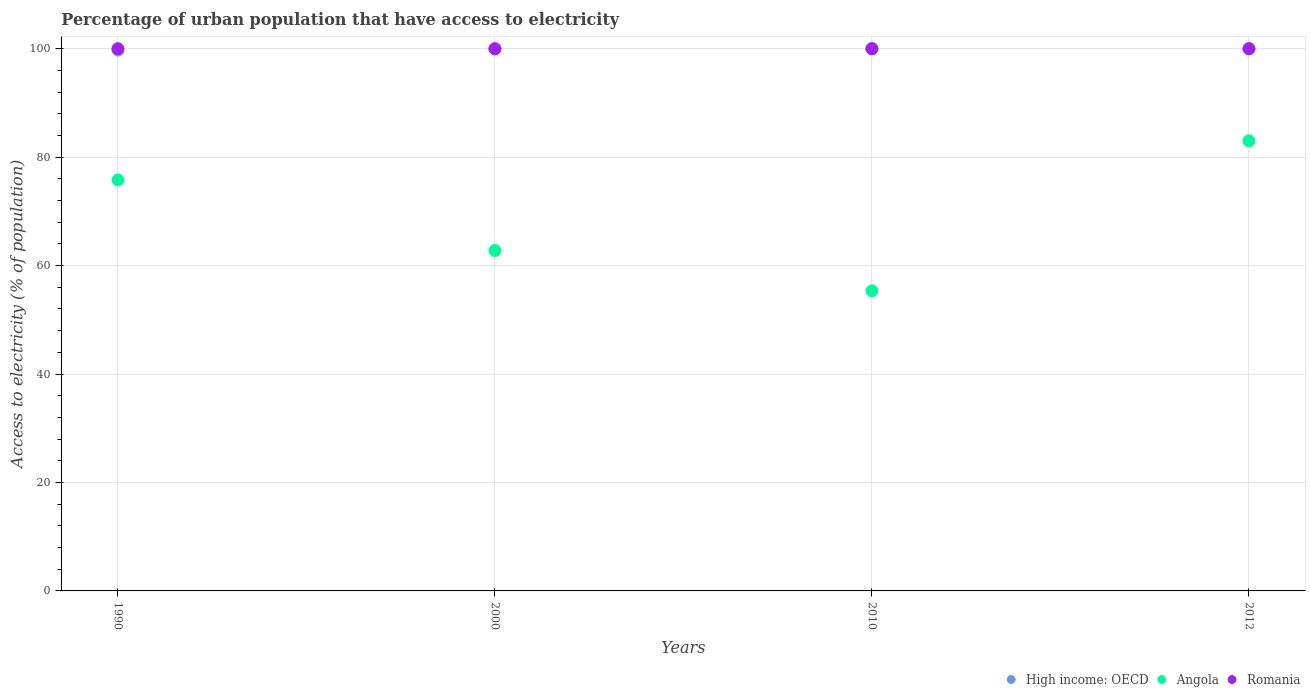How many different coloured dotlines are there?
Your response must be concise. 3. What is the percentage of urban population that have access to electricity in High income: OECD in 2010?
Keep it short and to the point. 99.98. Across all years, what is the maximum percentage of urban population that have access to electricity in High income: OECD?
Your answer should be compact. 100. Across all years, what is the minimum percentage of urban population that have access to electricity in High income: OECD?
Your response must be concise. 99.75. What is the total percentage of urban population that have access to electricity in High income: OECD in the graph?
Provide a succinct answer. 399.67. What is the difference between the percentage of urban population that have access to electricity in Angola in 1990 and that in 2010?
Give a very brief answer. 20.45. What is the difference between the percentage of urban population that have access to electricity in High income: OECD in 1990 and the percentage of urban population that have access to electricity in Angola in 2012?
Offer a very short reply. 16.75. What is the average percentage of urban population that have access to electricity in Romania per year?
Offer a terse response. 100. In the year 2010, what is the difference between the percentage of urban population that have access to electricity in Romania and percentage of urban population that have access to electricity in High income: OECD?
Provide a short and direct response. 0.02. In how many years, is the percentage of urban population that have access to electricity in Romania greater than 16 %?
Your response must be concise. 4. What is the ratio of the percentage of urban population that have access to electricity in High income: OECD in 1990 to that in 2010?
Make the answer very short. 1. Is the difference between the percentage of urban population that have access to electricity in Romania in 2000 and 2012 greater than the difference between the percentage of urban population that have access to electricity in High income: OECD in 2000 and 2012?
Offer a terse response. Yes. What is the difference between the highest and the lowest percentage of urban population that have access to electricity in High income: OECD?
Offer a terse response. 0.25. In how many years, is the percentage of urban population that have access to electricity in Romania greater than the average percentage of urban population that have access to electricity in Romania taken over all years?
Provide a succinct answer. 0. Is it the case that in every year, the sum of the percentage of urban population that have access to electricity in Romania and percentage of urban population that have access to electricity in Angola  is greater than the percentage of urban population that have access to electricity in High income: OECD?
Give a very brief answer. Yes. Is the percentage of urban population that have access to electricity in Romania strictly less than the percentage of urban population that have access to electricity in Angola over the years?
Provide a short and direct response. No. How many dotlines are there?
Keep it short and to the point. 3. What is the difference between two consecutive major ticks on the Y-axis?
Offer a terse response. 20. Are the values on the major ticks of Y-axis written in scientific E-notation?
Provide a succinct answer. No. Does the graph contain grids?
Offer a terse response. Yes. How many legend labels are there?
Provide a short and direct response. 3. How are the legend labels stacked?
Offer a very short reply. Horizontal. What is the title of the graph?
Make the answer very short. Percentage of urban population that have access to electricity. What is the label or title of the Y-axis?
Your response must be concise. Access to electricity (% of population). What is the Access to electricity (% of population) in High income: OECD in 1990?
Ensure brevity in your answer.  99.75. What is the Access to electricity (% of population) of Angola in 1990?
Make the answer very short. 75.79. What is the Access to electricity (% of population) in High income: OECD in 2000?
Ensure brevity in your answer.  99.94. What is the Access to electricity (% of population) of Angola in 2000?
Make the answer very short. 62.77. What is the Access to electricity (% of population) in High income: OECD in 2010?
Give a very brief answer. 99.98. What is the Access to electricity (% of population) in Angola in 2010?
Offer a very short reply. 55.35. What is the Access to electricity (% of population) of Romania in 2010?
Offer a very short reply. 100. What is the Access to electricity (% of population) of High income: OECD in 2012?
Provide a succinct answer. 100. What is the Access to electricity (% of population) of Angola in 2012?
Your response must be concise. 83. Across all years, what is the maximum Access to electricity (% of population) in High income: OECD?
Keep it short and to the point. 100. Across all years, what is the maximum Access to electricity (% of population) of Angola?
Keep it short and to the point. 83. Across all years, what is the maximum Access to electricity (% of population) of Romania?
Your answer should be very brief. 100. Across all years, what is the minimum Access to electricity (% of population) of High income: OECD?
Your response must be concise. 99.75. Across all years, what is the minimum Access to electricity (% of population) in Angola?
Keep it short and to the point. 55.35. What is the total Access to electricity (% of population) in High income: OECD in the graph?
Give a very brief answer. 399.67. What is the total Access to electricity (% of population) in Angola in the graph?
Make the answer very short. 276.91. What is the total Access to electricity (% of population) in Romania in the graph?
Make the answer very short. 400. What is the difference between the Access to electricity (% of population) in High income: OECD in 1990 and that in 2000?
Provide a short and direct response. -0.19. What is the difference between the Access to electricity (% of population) of Angola in 1990 and that in 2000?
Ensure brevity in your answer.  13.02. What is the difference between the Access to electricity (% of population) of High income: OECD in 1990 and that in 2010?
Your answer should be compact. -0.24. What is the difference between the Access to electricity (% of population) in Angola in 1990 and that in 2010?
Your response must be concise. 20.45. What is the difference between the Access to electricity (% of population) in High income: OECD in 1990 and that in 2012?
Provide a succinct answer. -0.25. What is the difference between the Access to electricity (% of population) in Angola in 1990 and that in 2012?
Offer a very short reply. -7.21. What is the difference between the Access to electricity (% of population) of Romania in 1990 and that in 2012?
Your answer should be very brief. 0. What is the difference between the Access to electricity (% of population) of High income: OECD in 2000 and that in 2010?
Offer a very short reply. -0.05. What is the difference between the Access to electricity (% of population) in Angola in 2000 and that in 2010?
Your answer should be compact. 7.42. What is the difference between the Access to electricity (% of population) in Romania in 2000 and that in 2010?
Your answer should be compact. 0. What is the difference between the Access to electricity (% of population) of High income: OECD in 2000 and that in 2012?
Your answer should be compact. -0.06. What is the difference between the Access to electricity (% of population) in Angola in 2000 and that in 2012?
Make the answer very short. -20.23. What is the difference between the Access to electricity (% of population) of Romania in 2000 and that in 2012?
Your answer should be compact. 0. What is the difference between the Access to electricity (% of population) in High income: OECD in 2010 and that in 2012?
Your response must be concise. -0.01. What is the difference between the Access to electricity (% of population) of Angola in 2010 and that in 2012?
Offer a terse response. -27.65. What is the difference between the Access to electricity (% of population) in Romania in 2010 and that in 2012?
Ensure brevity in your answer.  0. What is the difference between the Access to electricity (% of population) of High income: OECD in 1990 and the Access to electricity (% of population) of Angola in 2000?
Offer a terse response. 36.98. What is the difference between the Access to electricity (% of population) in High income: OECD in 1990 and the Access to electricity (% of population) in Romania in 2000?
Offer a terse response. -0.25. What is the difference between the Access to electricity (% of population) in Angola in 1990 and the Access to electricity (% of population) in Romania in 2000?
Offer a very short reply. -24.21. What is the difference between the Access to electricity (% of population) in High income: OECD in 1990 and the Access to electricity (% of population) in Angola in 2010?
Your response must be concise. 44.4. What is the difference between the Access to electricity (% of population) in High income: OECD in 1990 and the Access to electricity (% of population) in Romania in 2010?
Provide a succinct answer. -0.25. What is the difference between the Access to electricity (% of population) of Angola in 1990 and the Access to electricity (% of population) of Romania in 2010?
Your response must be concise. -24.21. What is the difference between the Access to electricity (% of population) of High income: OECD in 1990 and the Access to electricity (% of population) of Angola in 2012?
Your answer should be compact. 16.75. What is the difference between the Access to electricity (% of population) in High income: OECD in 1990 and the Access to electricity (% of population) in Romania in 2012?
Give a very brief answer. -0.25. What is the difference between the Access to electricity (% of population) of Angola in 1990 and the Access to electricity (% of population) of Romania in 2012?
Make the answer very short. -24.21. What is the difference between the Access to electricity (% of population) of High income: OECD in 2000 and the Access to electricity (% of population) of Angola in 2010?
Your response must be concise. 44.59. What is the difference between the Access to electricity (% of population) of High income: OECD in 2000 and the Access to electricity (% of population) of Romania in 2010?
Your response must be concise. -0.06. What is the difference between the Access to electricity (% of population) of Angola in 2000 and the Access to electricity (% of population) of Romania in 2010?
Offer a very short reply. -37.23. What is the difference between the Access to electricity (% of population) in High income: OECD in 2000 and the Access to electricity (% of population) in Angola in 2012?
Your answer should be very brief. 16.94. What is the difference between the Access to electricity (% of population) of High income: OECD in 2000 and the Access to electricity (% of population) of Romania in 2012?
Provide a short and direct response. -0.06. What is the difference between the Access to electricity (% of population) of Angola in 2000 and the Access to electricity (% of population) of Romania in 2012?
Offer a very short reply. -37.23. What is the difference between the Access to electricity (% of population) in High income: OECD in 2010 and the Access to electricity (% of population) in Angola in 2012?
Provide a short and direct response. 16.98. What is the difference between the Access to electricity (% of population) in High income: OECD in 2010 and the Access to electricity (% of population) in Romania in 2012?
Keep it short and to the point. -0.02. What is the difference between the Access to electricity (% of population) in Angola in 2010 and the Access to electricity (% of population) in Romania in 2012?
Offer a very short reply. -44.65. What is the average Access to electricity (% of population) of High income: OECD per year?
Provide a succinct answer. 99.92. What is the average Access to electricity (% of population) of Angola per year?
Keep it short and to the point. 69.23. In the year 1990, what is the difference between the Access to electricity (% of population) of High income: OECD and Access to electricity (% of population) of Angola?
Provide a succinct answer. 23.96. In the year 1990, what is the difference between the Access to electricity (% of population) in High income: OECD and Access to electricity (% of population) in Romania?
Offer a terse response. -0.25. In the year 1990, what is the difference between the Access to electricity (% of population) in Angola and Access to electricity (% of population) in Romania?
Your answer should be compact. -24.21. In the year 2000, what is the difference between the Access to electricity (% of population) in High income: OECD and Access to electricity (% of population) in Angola?
Your response must be concise. 37.16. In the year 2000, what is the difference between the Access to electricity (% of population) in High income: OECD and Access to electricity (% of population) in Romania?
Keep it short and to the point. -0.06. In the year 2000, what is the difference between the Access to electricity (% of population) of Angola and Access to electricity (% of population) of Romania?
Keep it short and to the point. -37.23. In the year 2010, what is the difference between the Access to electricity (% of population) in High income: OECD and Access to electricity (% of population) in Angola?
Make the answer very short. 44.64. In the year 2010, what is the difference between the Access to electricity (% of population) of High income: OECD and Access to electricity (% of population) of Romania?
Give a very brief answer. -0.02. In the year 2010, what is the difference between the Access to electricity (% of population) of Angola and Access to electricity (% of population) of Romania?
Offer a terse response. -44.65. In the year 2012, what is the difference between the Access to electricity (% of population) in High income: OECD and Access to electricity (% of population) in Angola?
Ensure brevity in your answer.  17. In the year 2012, what is the difference between the Access to electricity (% of population) in High income: OECD and Access to electricity (% of population) in Romania?
Make the answer very short. -0. In the year 2012, what is the difference between the Access to electricity (% of population) in Angola and Access to electricity (% of population) in Romania?
Offer a terse response. -17. What is the ratio of the Access to electricity (% of population) in Angola in 1990 to that in 2000?
Your answer should be compact. 1.21. What is the ratio of the Access to electricity (% of population) in Romania in 1990 to that in 2000?
Your answer should be compact. 1. What is the ratio of the Access to electricity (% of population) of High income: OECD in 1990 to that in 2010?
Offer a very short reply. 1. What is the ratio of the Access to electricity (% of population) in Angola in 1990 to that in 2010?
Keep it short and to the point. 1.37. What is the ratio of the Access to electricity (% of population) of Romania in 1990 to that in 2010?
Offer a terse response. 1. What is the ratio of the Access to electricity (% of population) in High income: OECD in 1990 to that in 2012?
Your answer should be compact. 1. What is the ratio of the Access to electricity (% of population) in Angola in 1990 to that in 2012?
Give a very brief answer. 0.91. What is the ratio of the Access to electricity (% of population) in Angola in 2000 to that in 2010?
Give a very brief answer. 1.13. What is the ratio of the Access to electricity (% of population) of Romania in 2000 to that in 2010?
Your response must be concise. 1. What is the ratio of the Access to electricity (% of population) of High income: OECD in 2000 to that in 2012?
Provide a short and direct response. 1. What is the ratio of the Access to electricity (% of population) in Angola in 2000 to that in 2012?
Make the answer very short. 0.76. What is the ratio of the Access to electricity (% of population) in Romania in 2000 to that in 2012?
Your response must be concise. 1. What is the ratio of the Access to electricity (% of population) in High income: OECD in 2010 to that in 2012?
Offer a terse response. 1. What is the ratio of the Access to electricity (% of population) of Angola in 2010 to that in 2012?
Keep it short and to the point. 0.67. What is the ratio of the Access to electricity (% of population) of Romania in 2010 to that in 2012?
Your answer should be compact. 1. What is the difference between the highest and the second highest Access to electricity (% of population) in High income: OECD?
Ensure brevity in your answer.  0.01. What is the difference between the highest and the second highest Access to electricity (% of population) in Angola?
Provide a succinct answer. 7.21. What is the difference between the highest and the second highest Access to electricity (% of population) in Romania?
Provide a succinct answer. 0. What is the difference between the highest and the lowest Access to electricity (% of population) of High income: OECD?
Ensure brevity in your answer.  0.25. What is the difference between the highest and the lowest Access to electricity (% of population) of Angola?
Make the answer very short. 27.65. 